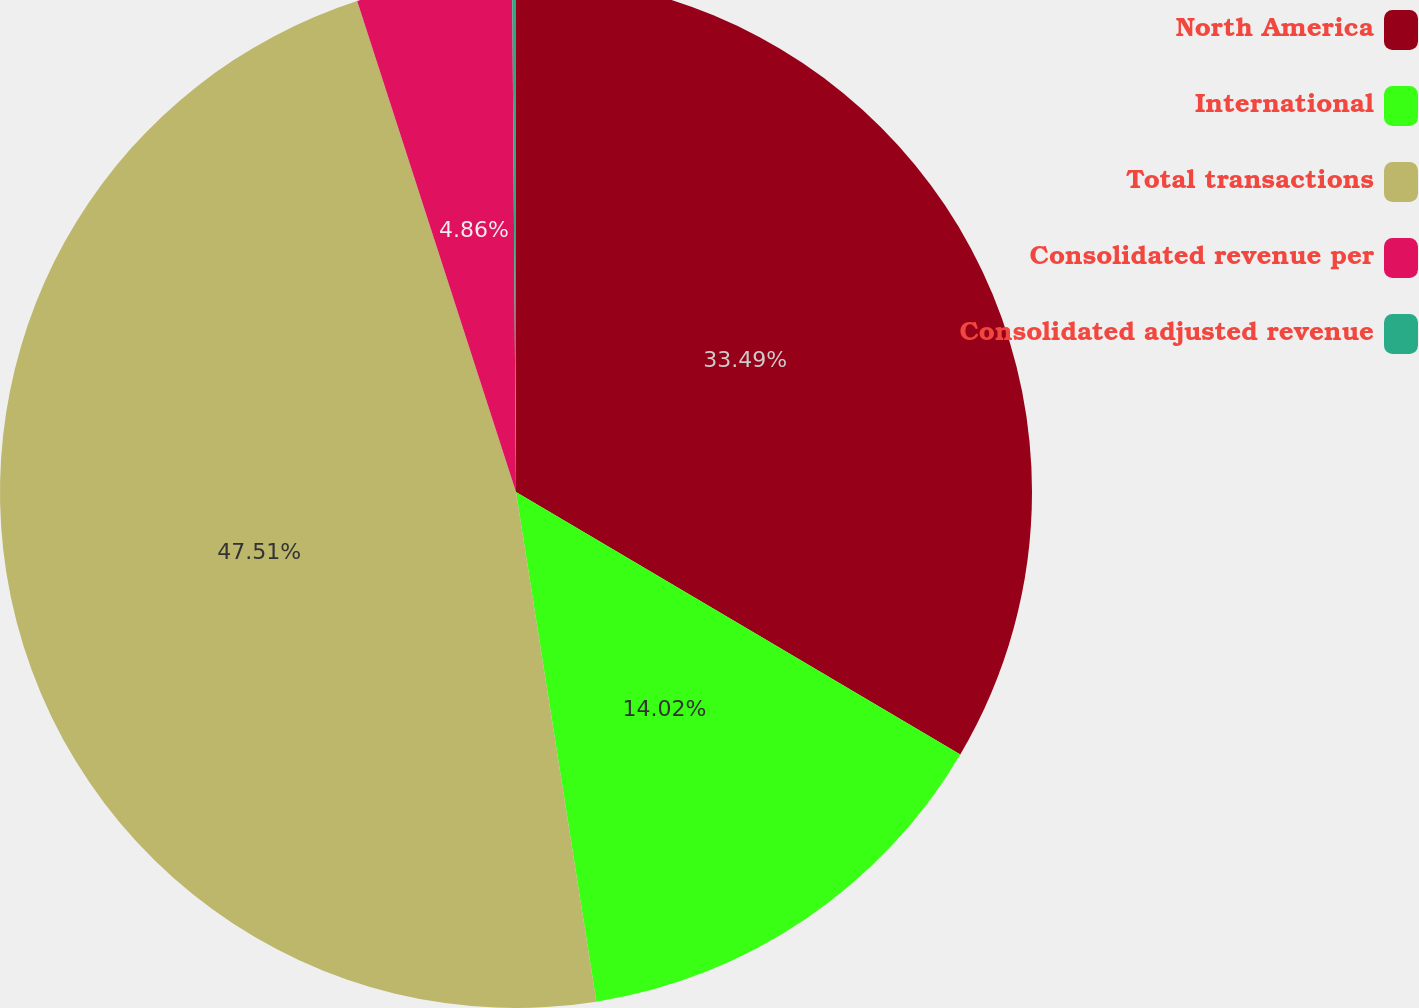Convert chart. <chart><loc_0><loc_0><loc_500><loc_500><pie_chart><fcel>North America<fcel>International<fcel>Total transactions<fcel>Consolidated revenue per<fcel>Consolidated adjusted revenue<nl><fcel>33.49%<fcel>14.02%<fcel>47.51%<fcel>4.86%<fcel>0.12%<nl></chart> 